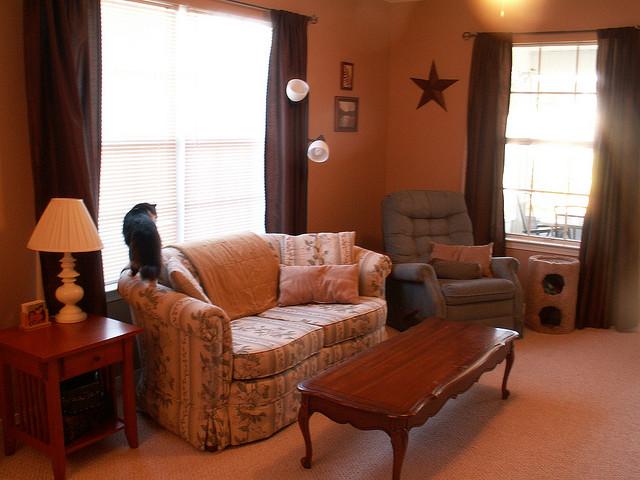Could something in this room be used to find the continents of the world?
Give a very brief answer. No. What color is the lazy boy?
Give a very brief answer. Gray. Which table has a lamp?
Quick response, please. Left. Would you allow your cat to sit on your couch?
Give a very brief answer. Yes. 